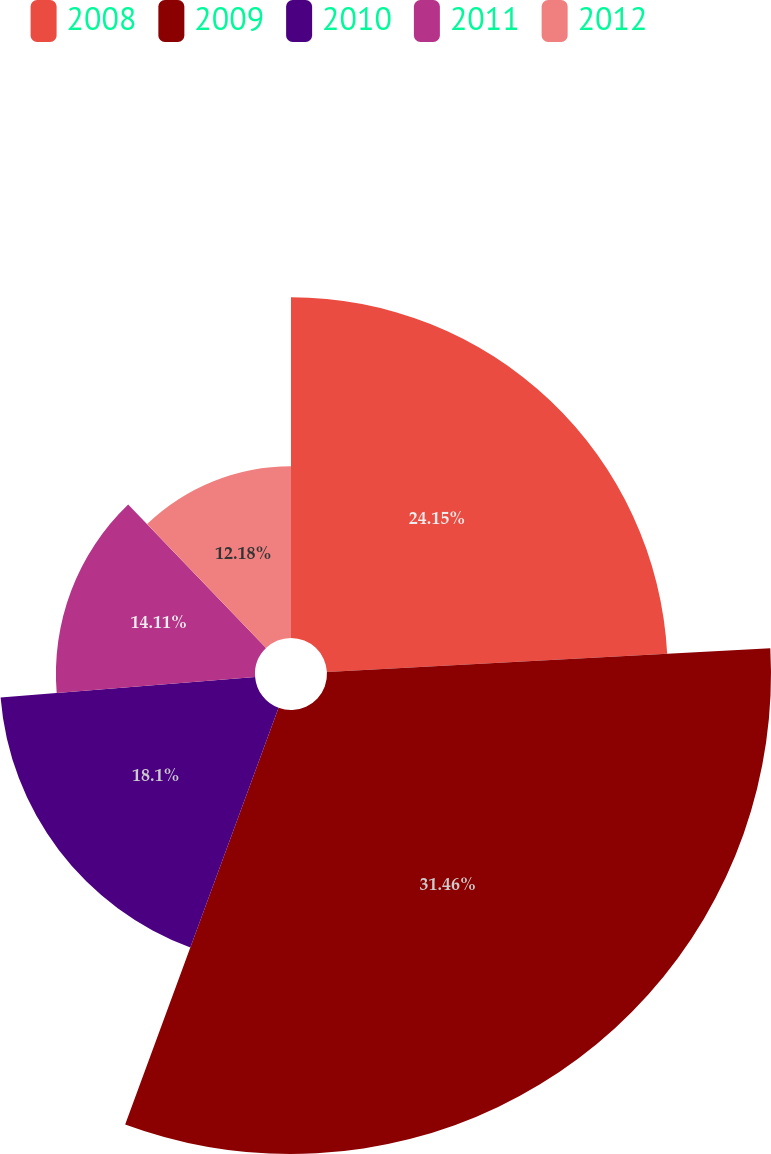<chart> <loc_0><loc_0><loc_500><loc_500><pie_chart><fcel>2008<fcel>2009<fcel>2010<fcel>2011<fcel>2012<nl><fcel>24.15%<fcel>31.47%<fcel>18.1%<fcel>14.11%<fcel>12.18%<nl></chart> 